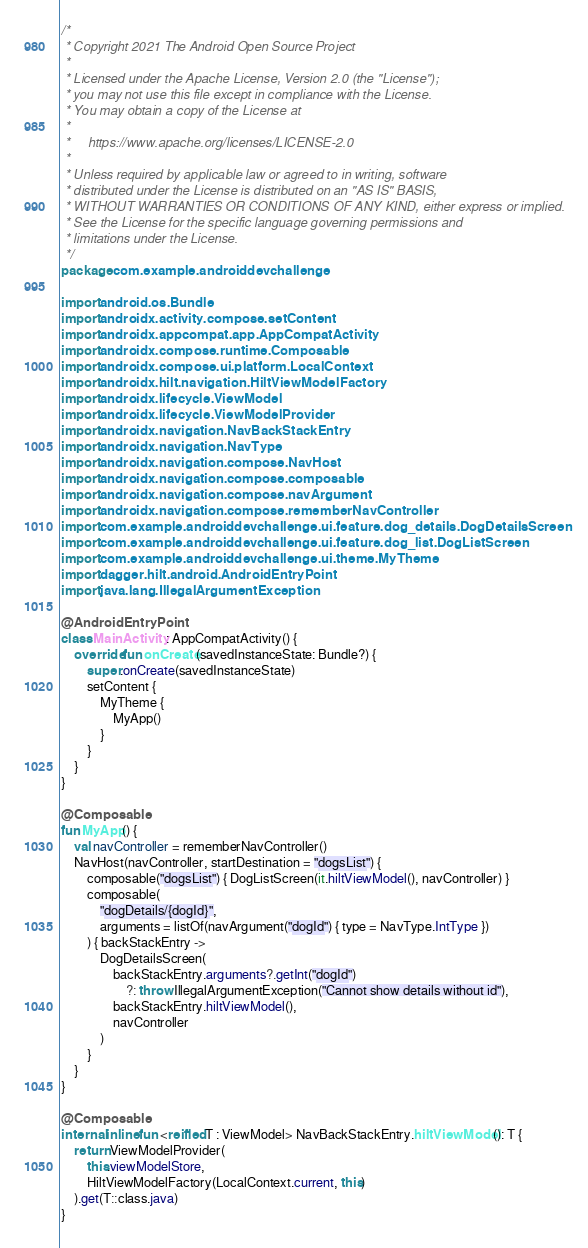Convert code to text. <code><loc_0><loc_0><loc_500><loc_500><_Kotlin_>/*
 * Copyright 2021 The Android Open Source Project
 *
 * Licensed under the Apache License, Version 2.0 (the "License");
 * you may not use this file except in compliance with the License.
 * You may obtain a copy of the License at
 *
 *     https://www.apache.org/licenses/LICENSE-2.0
 *
 * Unless required by applicable law or agreed to in writing, software
 * distributed under the License is distributed on an "AS IS" BASIS,
 * WITHOUT WARRANTIES OR CONDITIONS OF ANY KIND, either express or implied.
 * See the License for the specific language governing permissions and
 * limitations under the License.
 */
package com.example.androiddevchallenge

import android.os.Bundle
import androidx.activity.compose.setContent
import androidx.appcompat.app.AppCompatActivity
import androidx.compose.runtime.Composable
import androidx.compose.ui.platform.LocalContext
import androidx.hilt.navigation.HiltViewModelFactory
import androidx.lifecycle.ViewModel
import androidx.lifecycle.ViewModelProvider
import androidx.navigation.NavBackStackEntry
import androidx.navigation.NavType
import androidx.navigation.compose.NavHost
import androidx.navigation.compose.composable
import androidx.navigation.compose.navArgument
import androidx.navigation.compose.rememberNavController
import com.example.androiddevchallenge.ui.feature.dog_details.DogDetailsScreen
import com.example.androiddevchallenge.ui.feature.dog_list.DogListScreen
import com.example.androiddevchallenge.ui.theme.MyTheme
import dagger.hilt.android.AndroidEntryPoint
import java.lang.IllegalArgumentException

@AndroidEntryPoint
class MainActivity : AppCompatActivity() {
    override fun onCreate(savedInstanceState: Bundle?) {
        super.onCreate(savedInstanceState)
        setContent {
            MyTheme {
                MyApp()
            }
        }
    }
}

@Composable
fun MyApp() {
    val navController = rememberNavController()
    NavHost(navController, startDestination = "dogsList") {
        composable("dogsList") { DogListScreen(it.hiltViewModel(), navController) }
        composable(
            "dogDetails/{dogId}",
            arguments = listOf(navArgument("dogId") { type = NavType.IntType })
        ) { backStackEntry ->
            DogDetailsScreen(
                backStackEntry.arguments?.getInt("dogId")
                    ?: throw IllegalArgumentException("Cannot show details without id"),
                backStackEntry.hiltViewModel(),
                navController
            )
        }
    }
}

@Composable
internal inline fun <reified T : ViewModel> NavBackStackEntry.hiltViewModel(): T {
    return ViewModelProvider(
        this.viewModelStore,
        HiltViewModelFactory(LocalContext.current, this)
    ).get(T::class.java)
}
</code> 